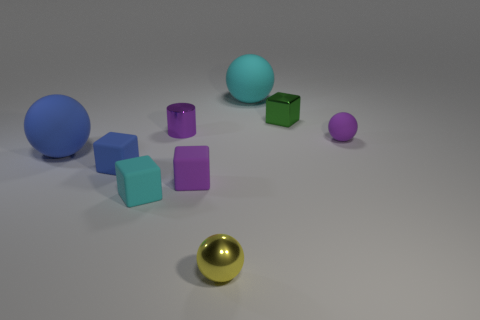Subtract all green balls. Subtract all blue blocks. How many balls are left? 4 Add 1 blue rubber cylinders. How many objects exist? 10 Subtract all cubes. How many objects are left? 5 Subtract all small things. Subtract all tiny cylinders. How many objects are left? 1 Add 5 yellow spheres. How many yellow spheres are left? 6 Add 3 tiny rubber cylinders. How many tiny rubber cylinders exist? 3 Subtract 0 red blocks. How many objects are left? 9 